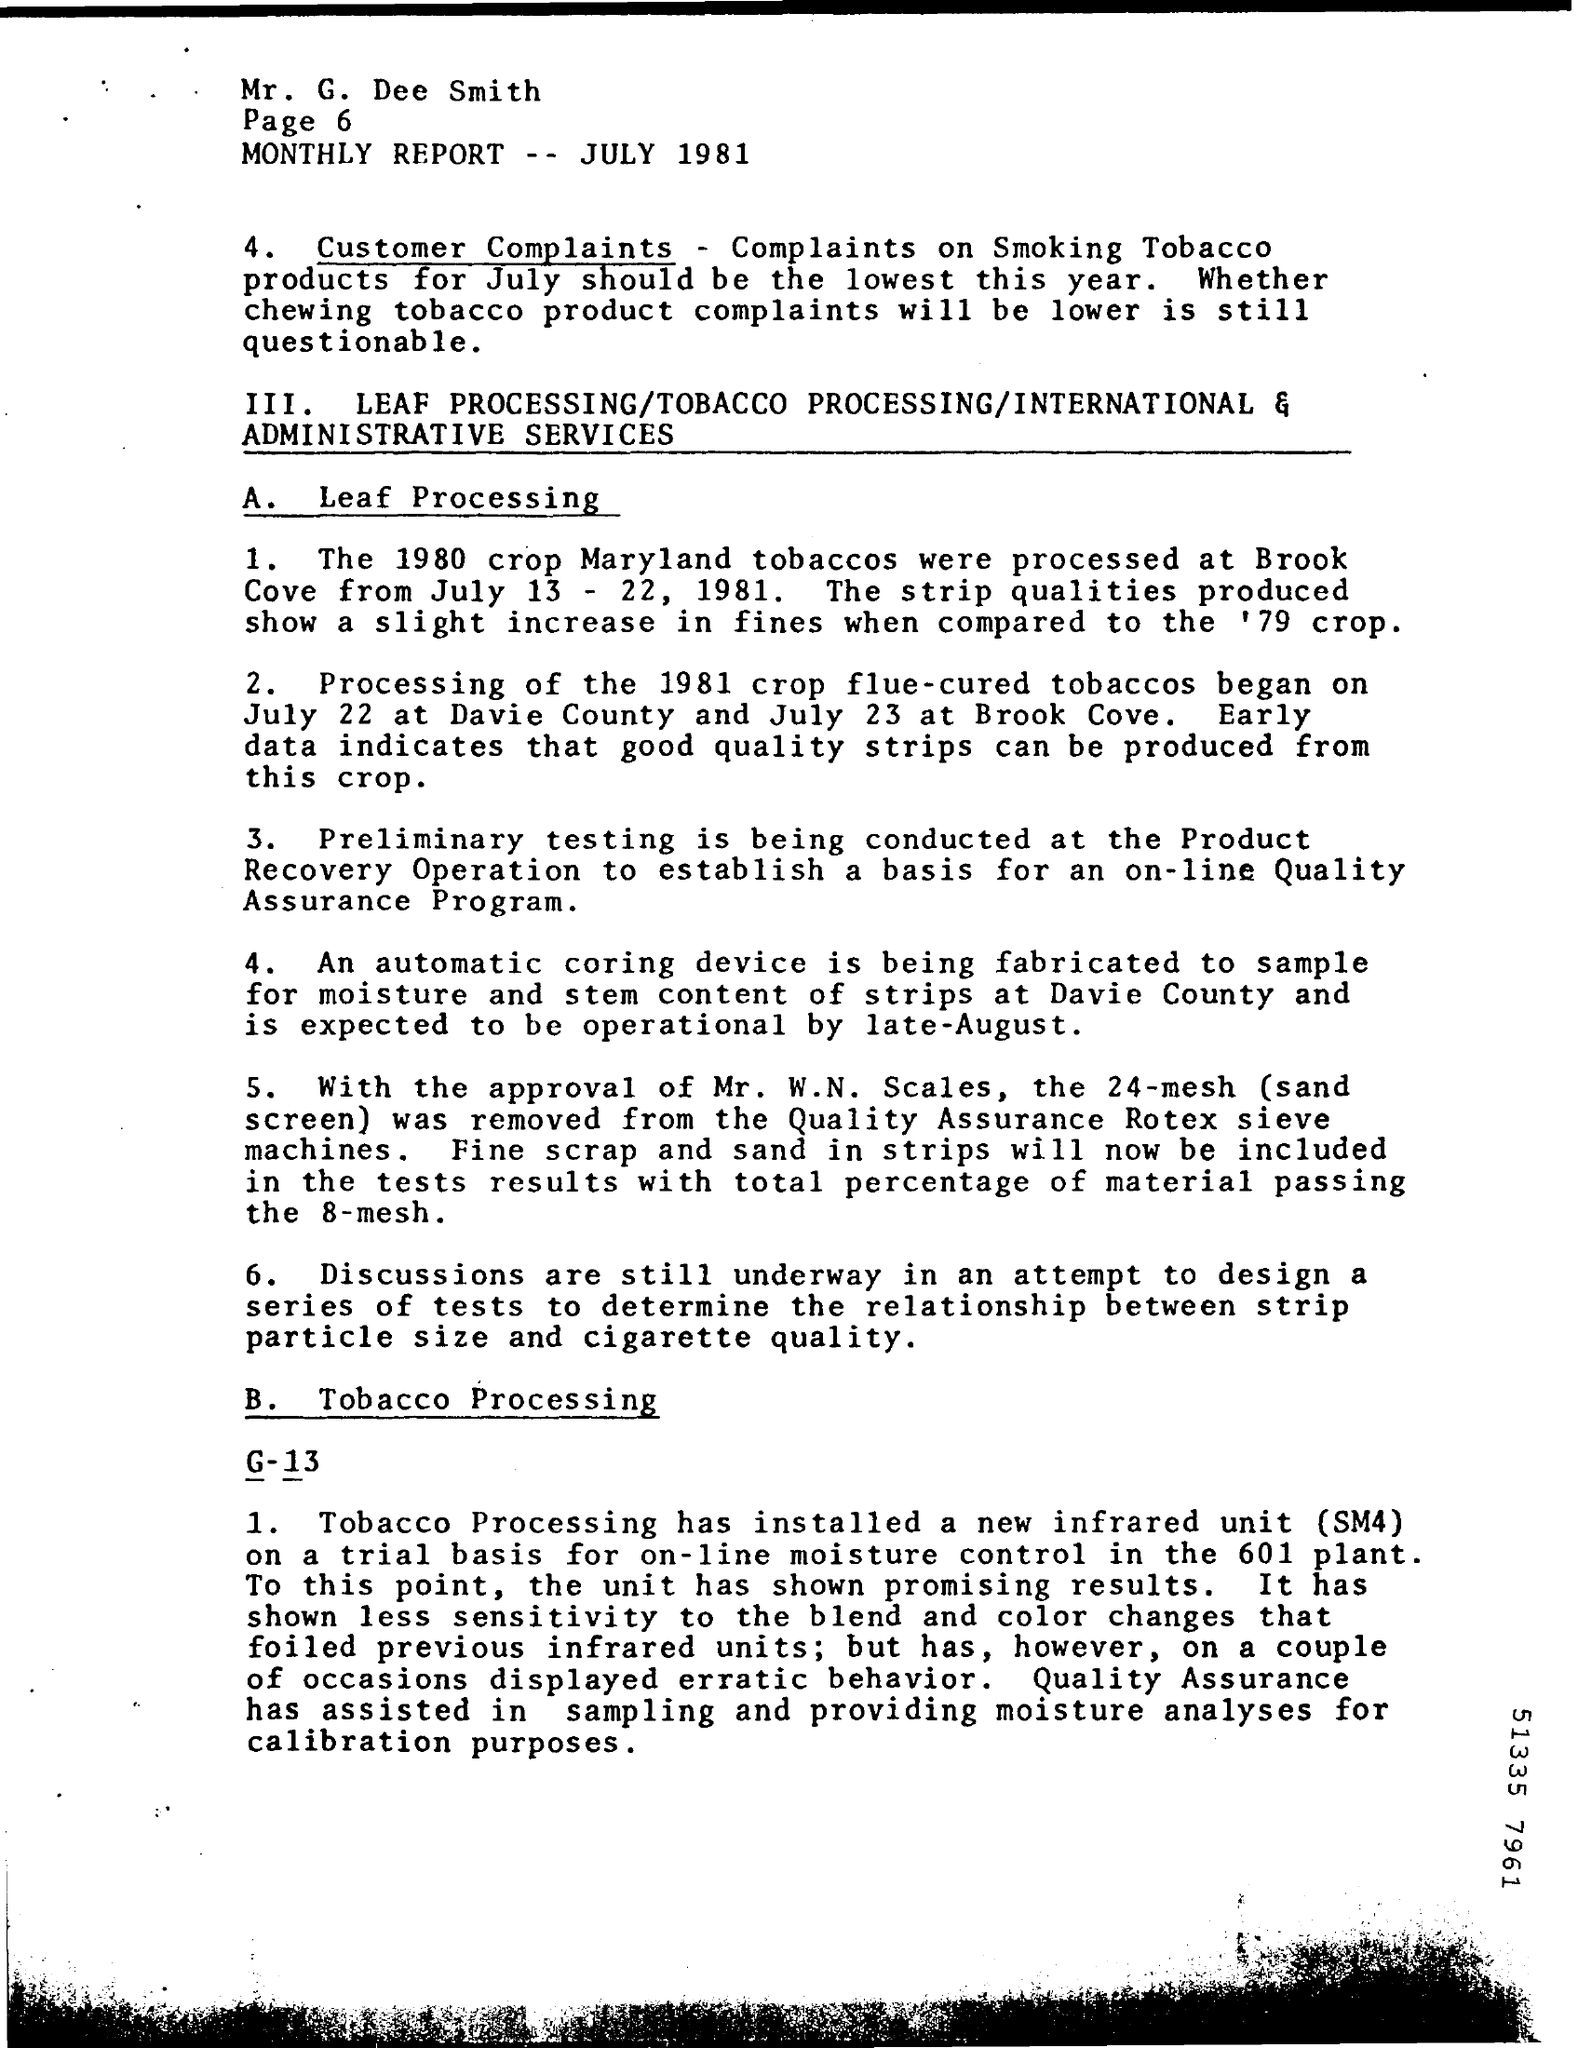Point out several critical features in this image. The automatic coring device is being used to sample the moisture and stem content of strips. In 1980, the Maryland tobacco crop was processed at Brook Cove. 